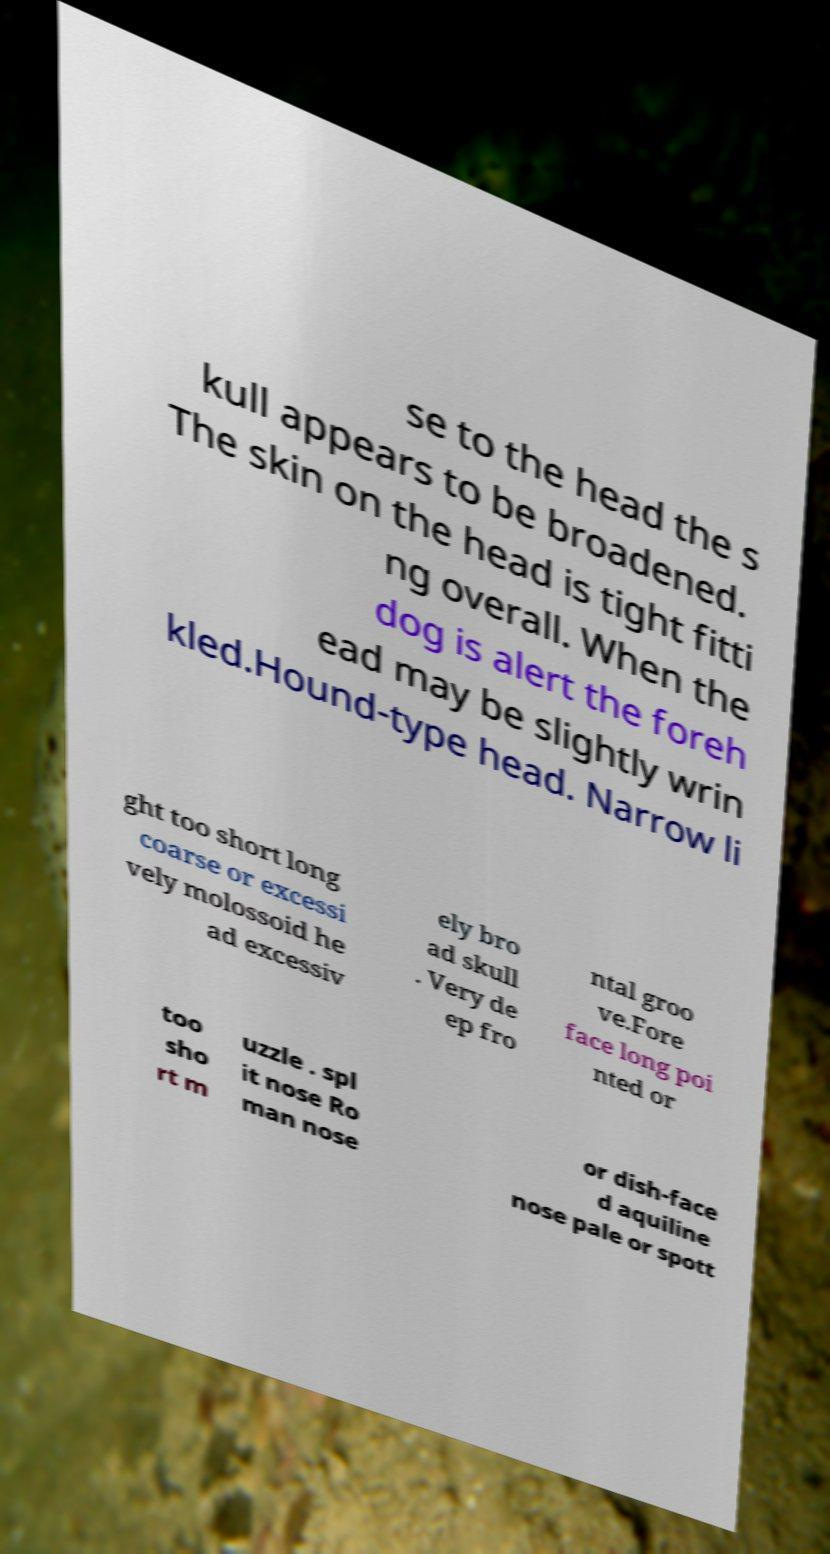For documentation purposes, I need the text within this image transcribed. Could you provide that? se to the head the s kull appears to be broadened. The skin on the head is tight fitti ng overall. When the dog is alert the foreh ead may be slightly wrin kled.Hound-type head. Narrow li ght too short long coarse or excessi vely molossoid he ad excessiv ely bro ad skull . Very de ep fro ntal groo ve.Fore face long poi nted or too sho rt m uzzle . spl it nose Ro man nose or dish-face d aquiline nose pale or spott 